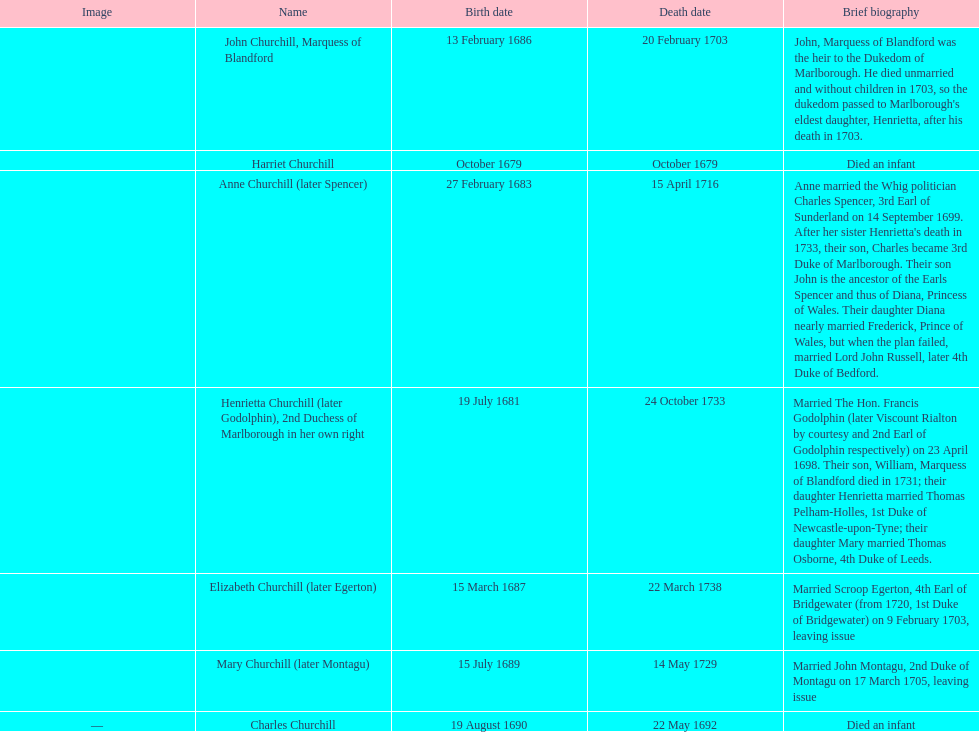Who was born before henrietta churchhill? Harriet Churchill. Would you be able to parse every entry in this table? {'header': ['Image', 'Name', 'Birth date', 'Death date', 'Brief biography'], 'rows': [['', 'John Churchill, Marquess of Blandford', '13 February 1686', '20 February 1703', "John, Marquess of Blandford was the heir to the Dukedom of Marlborough. He died unmarried and without children in 1703, so the dukedom passed to Marlborough's eldest daughter, Henrietta, after his death in 1703."], ['', 'Harriet Churchill', 'October 1679', 'October 1679', 'Died an infant'], ['', 'Anne Churchill (later Spencer)', '27 February 1683', '15 April 1716', "Anne married the Whig politician Charles Spencer, 3rd Earl of Sunderland on 14 September 1699. After her sister Henrietta's death in 1733, their son, Charles became 3rd Duke of Marlborough. Their son John is the ancestor of the Earls Spencer and thus of Diana, Princess of Wales. Their daughter Diana nearly married Frederick, Prince of Wales, but when the plan failed, married Lord John Russell, later 4th Duke of Bedford."], ['', 'Henrietta Churchill (later Godolphin), 2nd Duchess of Marlborough in her own right', '19 July 1681', '24 October 1733', 'Married The Hon. Francis Godolphin (later Viscount Rialton by courtesy and 2nd Earl of Godolphin respectively) on 23 April 1698. Their son, William, Marquess of Blandford died in 1731; their daughter Henrietta married Thomas Pelham-Holles, 1st Duke of Newcastle-upon-Tyne; their daughter Mary married Thomas Osborne, 4th Duke of Leeds.'], ['', 'Elizabeth Churchill (later Egerton)', '15 March 1687', '22 March 1738', 'Married Scroop Egerton, 4th Earl of Bridgewater (from 1720, 1st Duke of Bridgewater) on 9 February 1703, leaving issue'], ['', 'Mary Churchill (later Montagu)', '15 July 1689', '14 May 1729', 'Married John Montagu, 2nd Duke of Montagu on 17 March 1705, leaving issue'], ['—', 'Charles Churchill', '19 August 1690', '22 May 1692', 'Died an infant']]} 